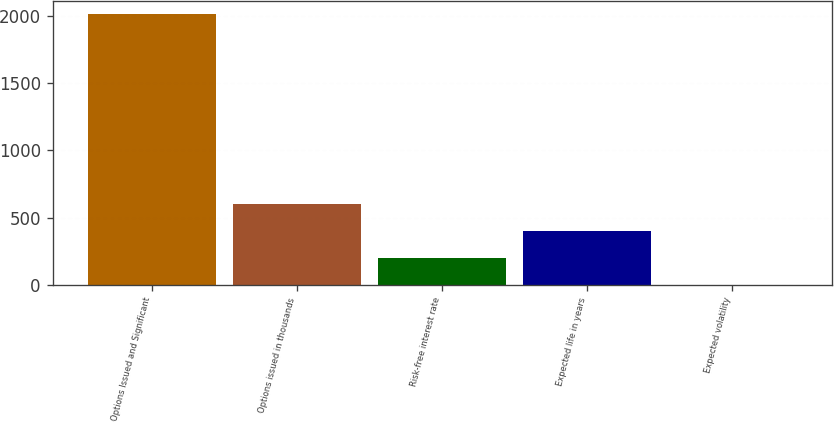Convert chart. <chart><loc_0><loc_0><loc_500><loc_500><bar_chart><fcel>Options Issued and Significant<fcel>Options issued in thousands<fcel>Risk-free interest rate<fcel>Expected life in years<fcel>Expected volatility<nl><fcel>2014<fcel>604.38<fcel>201.64<fcel>403.01<fcel>0.27<nl></chart> 